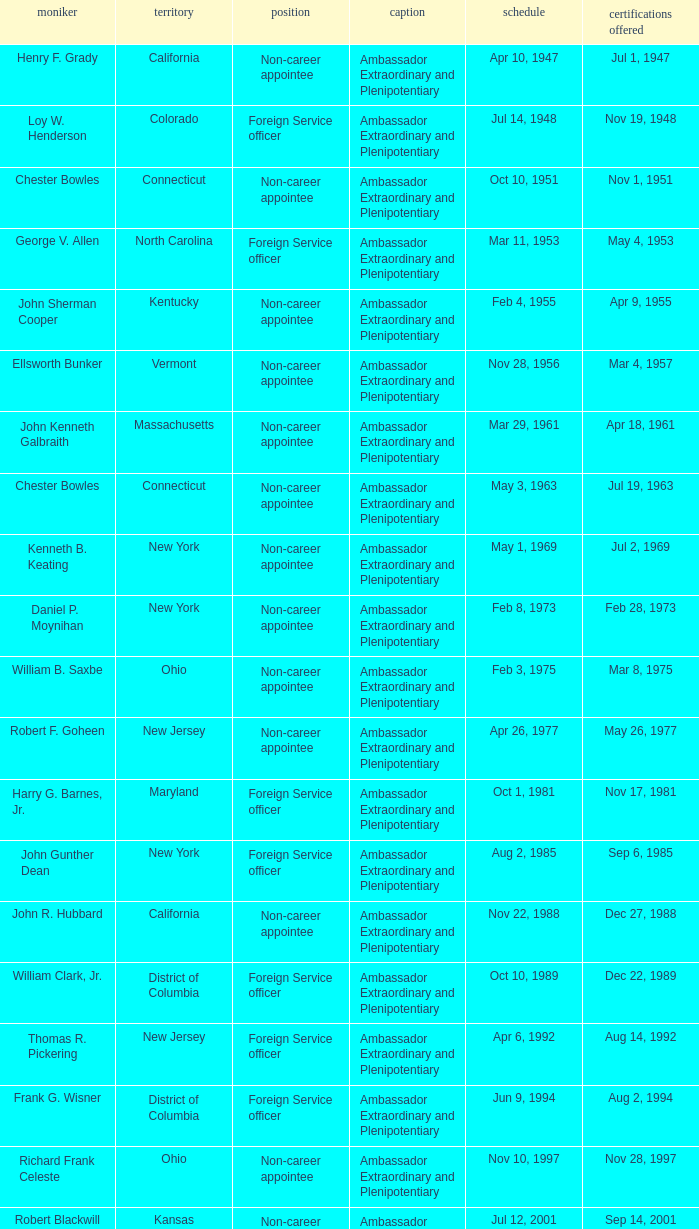What day were credentials presented for vermont? Mar 4, 1957. 